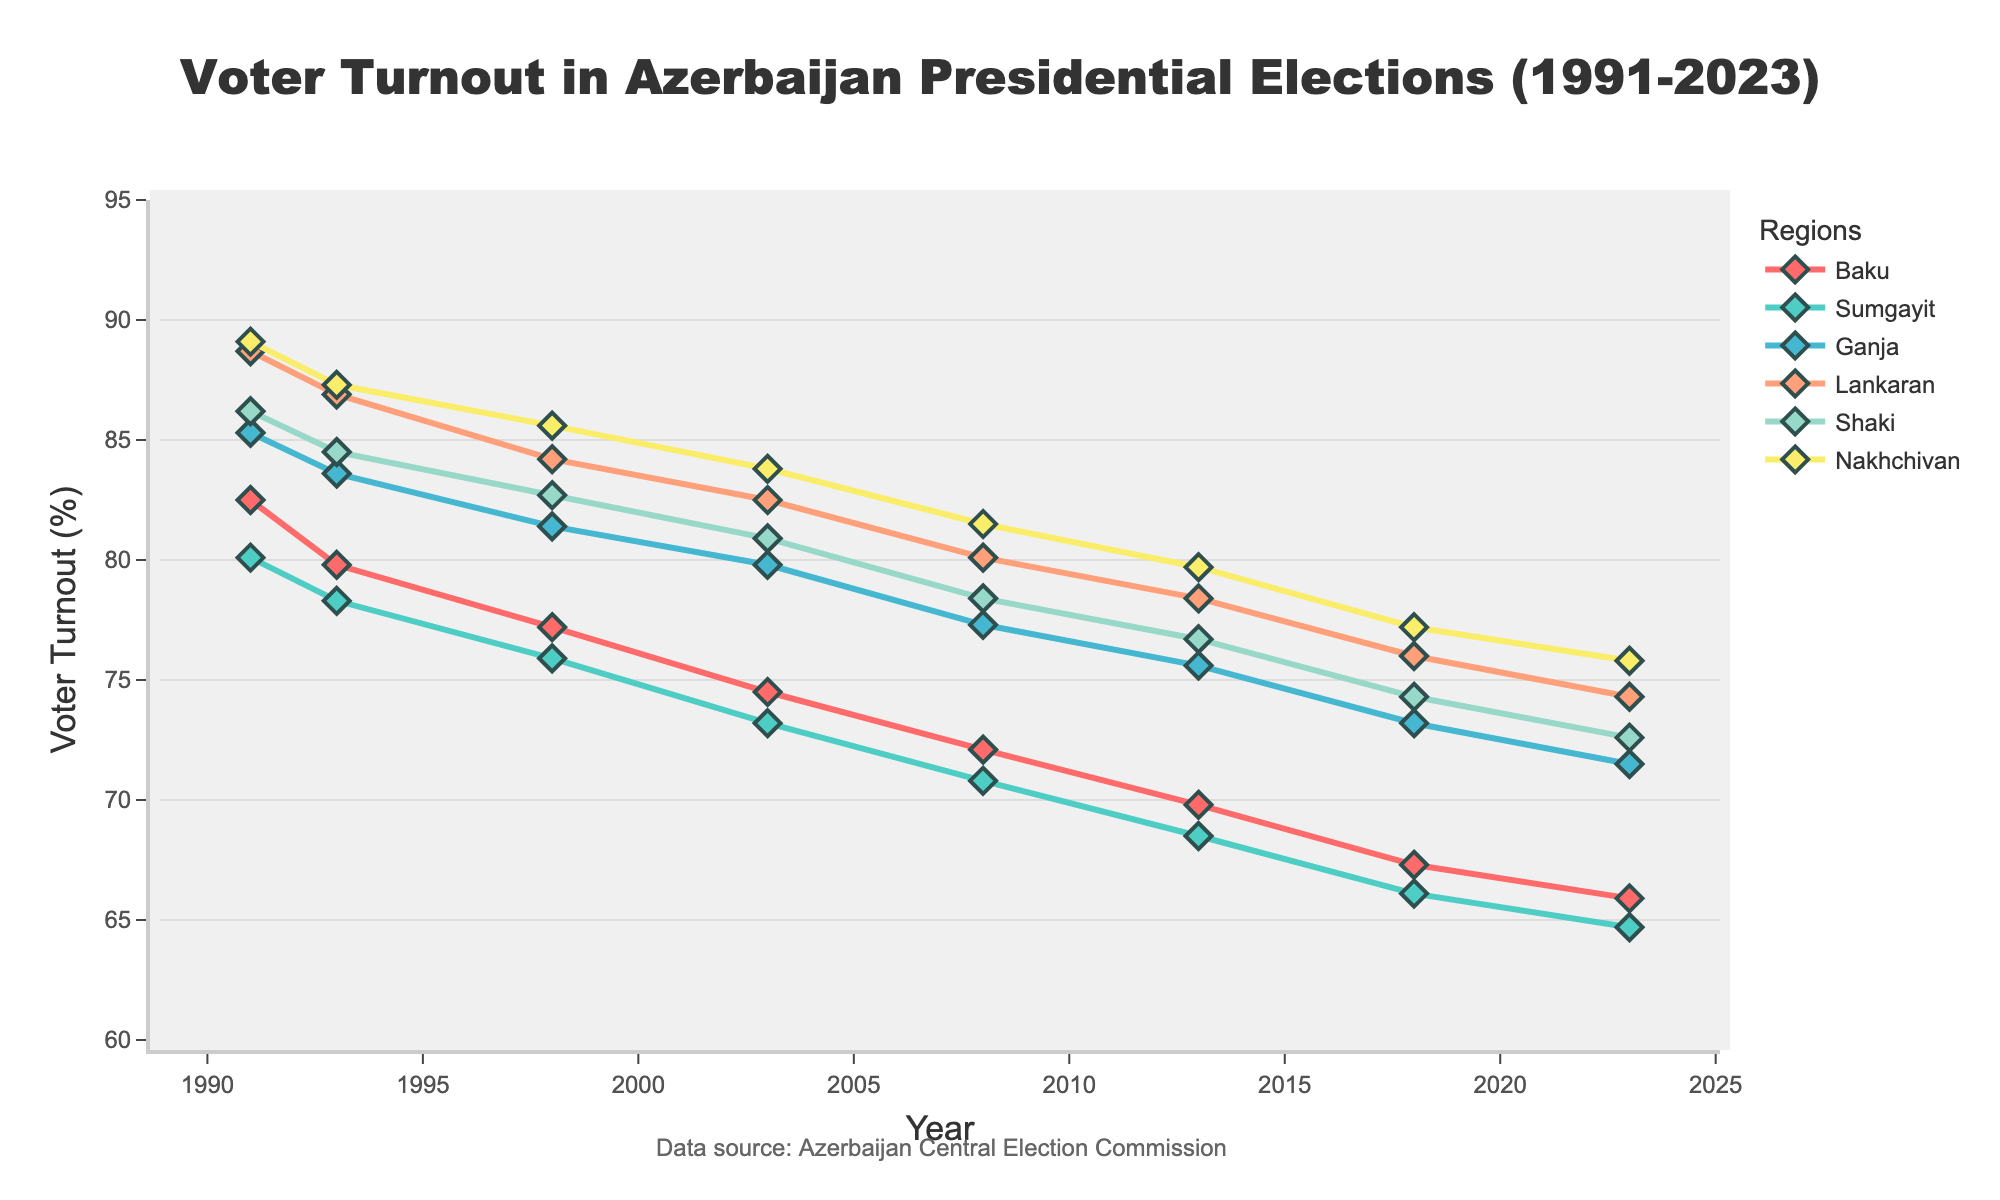What was the voter turnout in Baku in 1991 compared to 2023? In 1991, the voter turnout in Baku was 82.5%. By 2023, it had decreased to 65.9%. This is a simple comparison of the voter turnout values for those two years.
Answer: In 1991, it was 82.5%, and in 2023, it was 65.9% Which region had the highest voter turnout in 2018? To find the region with the highest voter turnout in 2018, we need to look at the figures for all the regions in that year. The values are Baku (67.3%), Sumgayit (66.1%), Ganja (73.2%), Lankaran (76.0%), Shaki (74.3%), and Nakhchivan (77.2%). Nakhchivan has the highest voter turnout among these.
Answer: Nakhchivan How did the voter turnout in Lankaran change from 1991 to 2018? In 1991, the voter turnout in Lankaran was 88.7%. By 2018, the voter turnout in Lankaran had decreased to 76.0%. This requires subtracting the 2018 value from the 1991 value: 88.7% - 76.0% = 12.7% decrease.
Answer: Decreased by 12.7% In which year did Sumgayit's voter turnout drop below 70%? Reviewing the voter turnout values for Sumgayit, we see 1991 (80.1%), 1993 (78.3%), 1998 (75.9%), 2003 (73.2%), 2008 (70.8%), 2013 (68.5%), 2018 (66.1%), and 2023 (64.7%). The first year it dropped below 70% was 2013.
Answer: 2013 Which region experienced the smallest decline in voter turnout from 1991 to 2023? To determine this, look at the voter turnout values in 1991 and 2023 for each region and calculate the decline for each:
- Baku: 82.5% to 65.9% = 82.5 - 65.9 = 16.6%
- Sumgayit: 80.1% to 64.7% = 80.1 - 64.7 = 15.4%
- Ganja: 85.3% to 71.5% = 85.3 - 71.5 = 13.8%
- Lankaran: 88.7% to 74.3% = 88.7 - 74.3 = 14.4%
- Shaki: 86.2% to 72.6% = 86.2 - 72.6 = 13.6%
- Nakhchivan: 89.1% to 75.8% = 89.1 - 75.8 = 13.3%
                
Nakhchivan experienced the smallest decline (13.3%).
Answer: Nakhchivan Which region shows the most consistent voter turnout decrease over time? Consistency in this context can be interpreted by observing a steady decline in the voter turnout values over the years. By reviewing the trends in the chart, Sumgayit shows a regular decrease without any significant deviations over the years.
Answer: Sumgayit What is the average voter turnout in Ganja over the entire period? The voter turnout in Ganja for each election year is 1991 (85.3%), 1993 (83.6%), 1998 (81.4%), 2003 (79.8%), 2008 (77.3%), 2013 (75.6%), 2018 (73.2%), 2023 (71.5%). To find the average, we sum these values and then divide by the number of data points: 
(85.3 + 83.6 + 81.4 + 79.8 + 77.3 + 75.6 + 73.2 + 71.5) / 8 = 627.7 / 8 = 78.4625.
Answer: 78.46% Compare the voter turnout trends between Baku and Nakhchivan. Baku's voter turnout starts at 82.5% in 1991 and declines steadily each election, reaching 65.9% in 2023. Nakhchivan's voter turnout starts higher at 89.1% in 1991 and also declines steadily but remains higher than Baku's throughout the period, finishing at 75.8% in 2023.
Answer: Both decline, but Nakhchivan consistently has higher turnout What was the combined voter turnout for Shaki and Lankaran in 2008? Sum the voter turnout values for Shaki (78.4%) and Lankaran (80.1%) in 2008: 78.4 + 80.1 = 158.5%.
Answer: 158.5% 